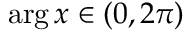<formula> <loc_0><loc_0><loc_500><loc_500>\arg x \in ( 0 , 2 \pi )</formula> 